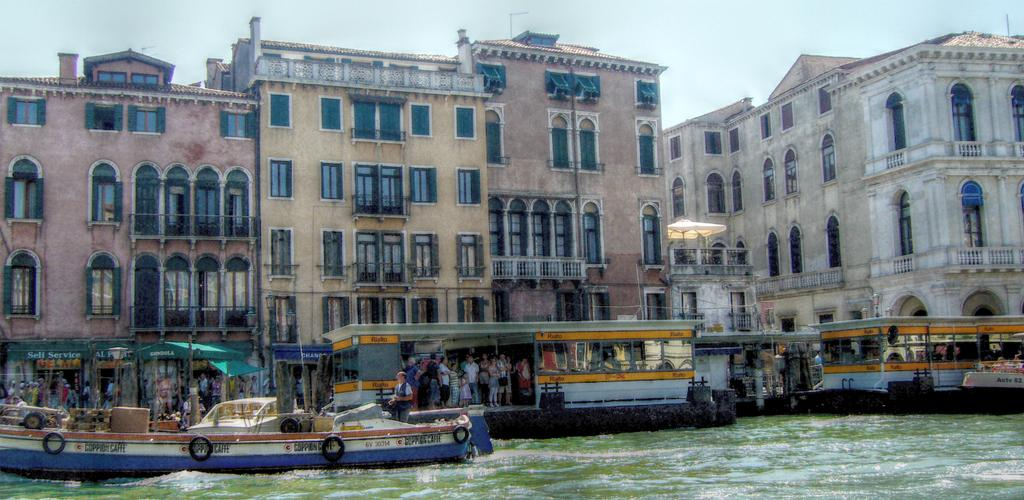What type of structures can be seen in the image? There are buildings in the image. What objects are present near the water? There are boards and a boat on the water. What mode of transportation can be seen on the road? There are buses on the road. What is visible in the background of the image? The sky is visible in the background of the image. What color is the crayon used to draw the zinc in the image? There is no crayon or zinc present in the image. What level of water is visible in the image? The image does not provide information about the level of water; it only shows that water is visible at the bottom of the image. 